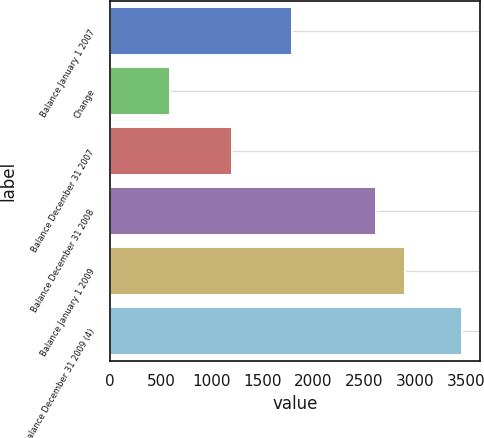Convert chart to OTSL. <chart><loc_0><loc_0><loc_500><loc_500><bar_chart><fcel>Balance January 1 2007<fcel>Change<fcel>Balance December 31 2007<fcel>Balance December 31 2008<fcel>Balance January 1 2009<fcel>Balance December 31 2009 (4)<nl><fcel>1786<fcel>590<fcel>1196<fcel>2615<fcel>2902.1<fcel>3461<nl></chart> 